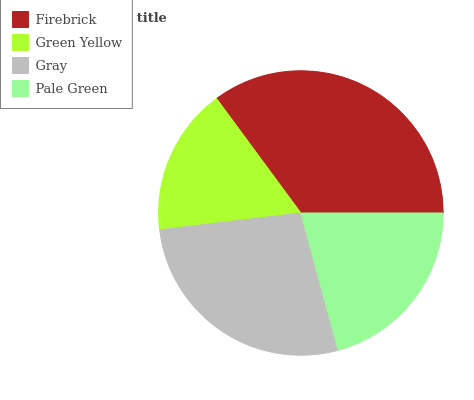Is Green Yellow the minimum?
Answer yes or no. Yes. Is Firebrick the maximum?
Answer yes or no. Yes. Is Gray the minimum?
Answer yes or no. No. Is Gray the maximum?
Answer yes or no. No. Is Gray greater than Green Yellow?
Answer yes or no. Yes. Is Green Yellow less than Gray?
Answer yes or no. Yes. Is Green Yellow greater than Gray?
Answer yes or no. No. Is Gray less than Green Yellow?
Answer yes or no. No. Is Gray the high median?
Answer yes or no. Yes. Is Pale Green the low median?
Answer yes or no. Yes. Is Green Yellow the high median?
Answer yes or no. No. Is Green Yellow the low median?
Answer yes or no. No. 